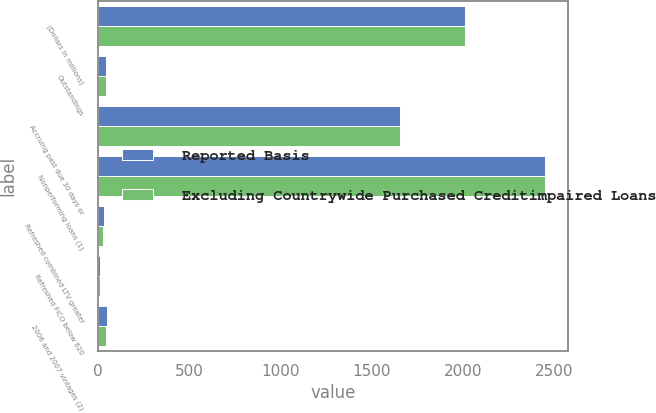Convert chart to OTSL. <chart><loc_0><loc_0><loc_500><loc_500><stacked_bar_chart><ecel><fcel>(Dollars in millions)<fcel>Outstandings<fcel>Accruing past due 30 days or<fcel>Nonperforming loans (1)<fcel>Refreshed combined LTV greater<fcel>Refreshed FICO below 620<fcel>2006 and 2007 vintages (2)<nl><fcel>Reported Basis<fcel>2011<fcel>48<fcel>1658<fcel>2453<fcel>36<fcel>13<fcel>50<nl><fcel>Excluding Countrywide Purchased Creditimpaired Loans<fcel>2011<fcel>48<fcel>1658<fcel>2453<fcel>32<fcel>12<fcel>46<nl></chart> 